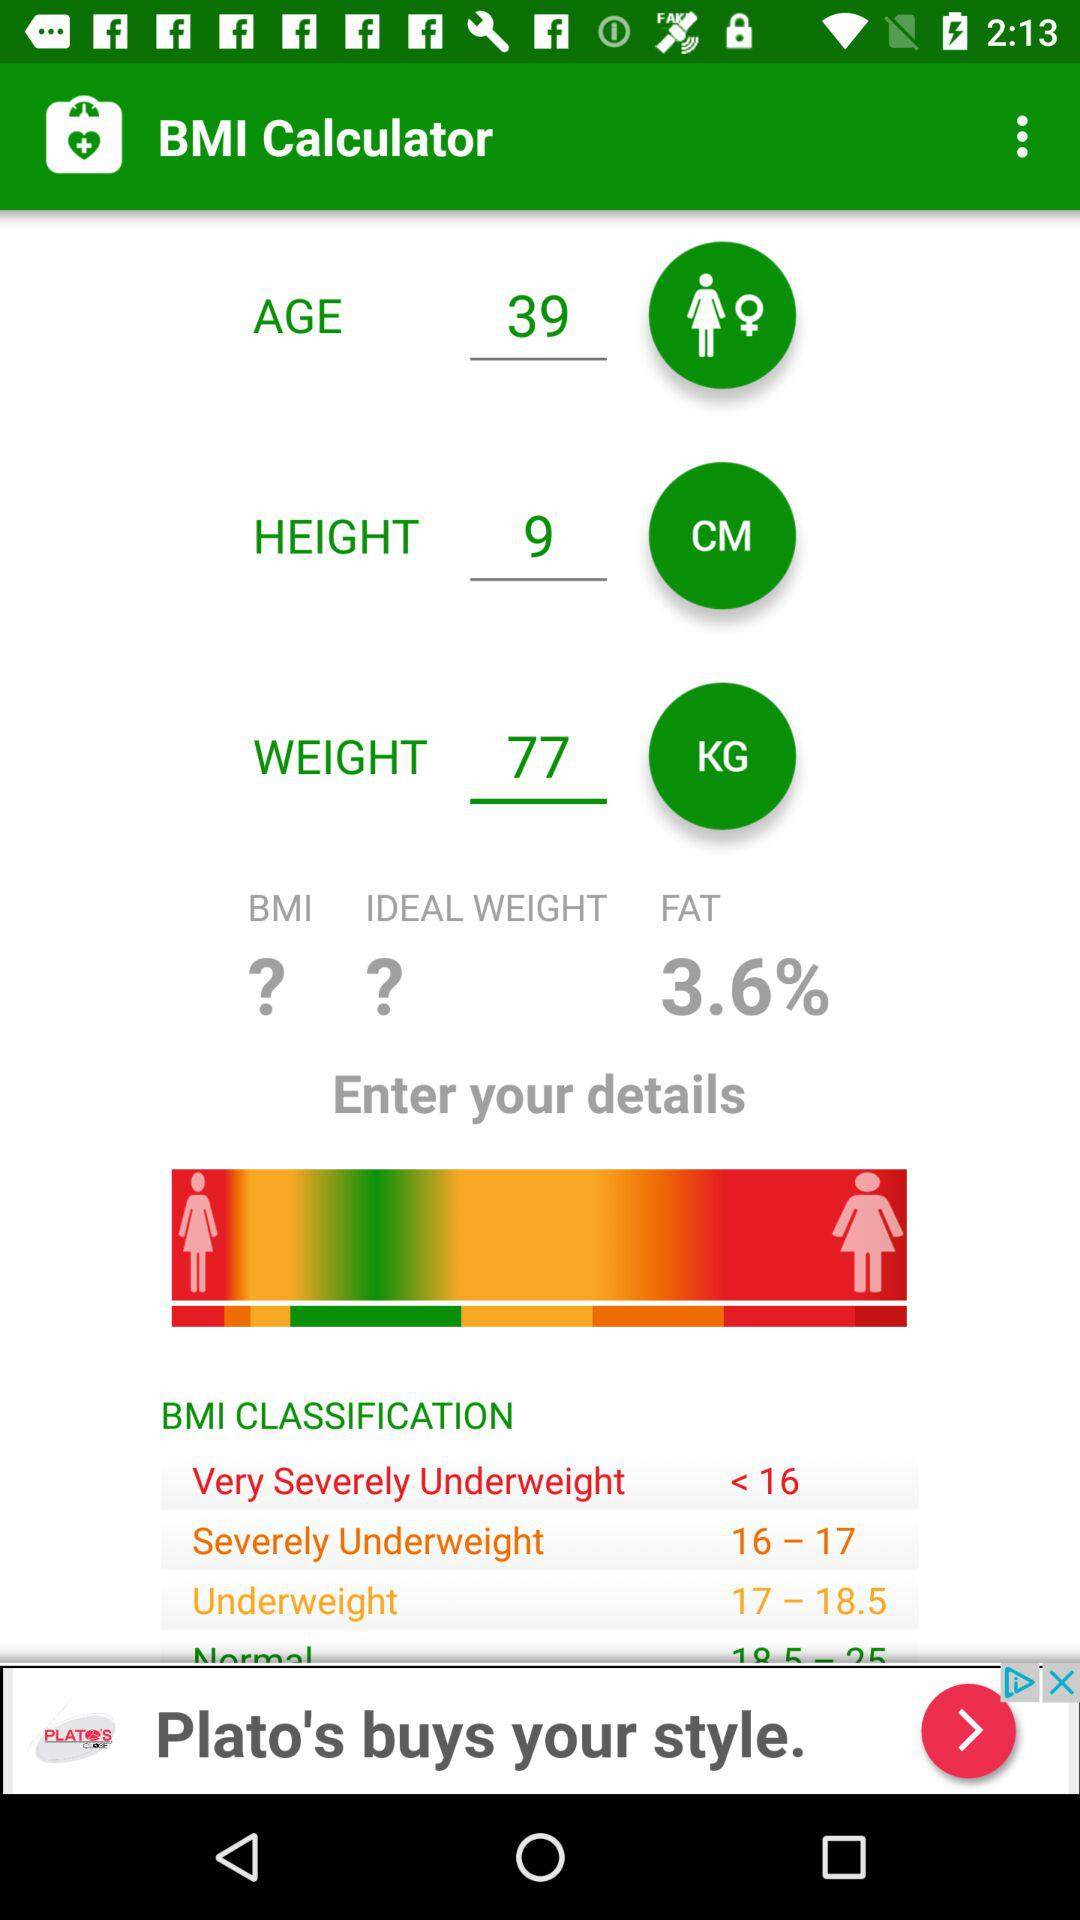What is the weight? The weight is 77 kg. 